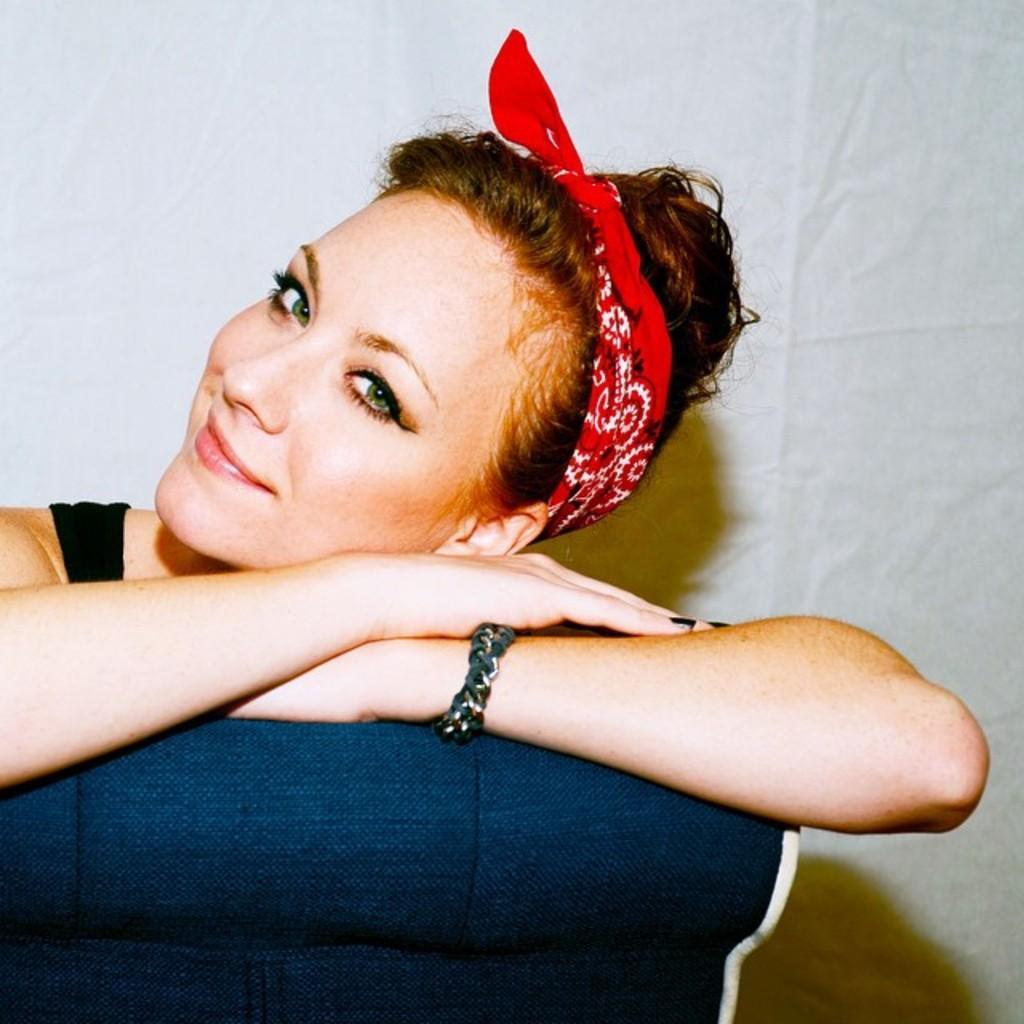Can you describe this image briefly? In this image, we can see there is a woman, smiling and sitting on a violet color object. And the background is white in color. 